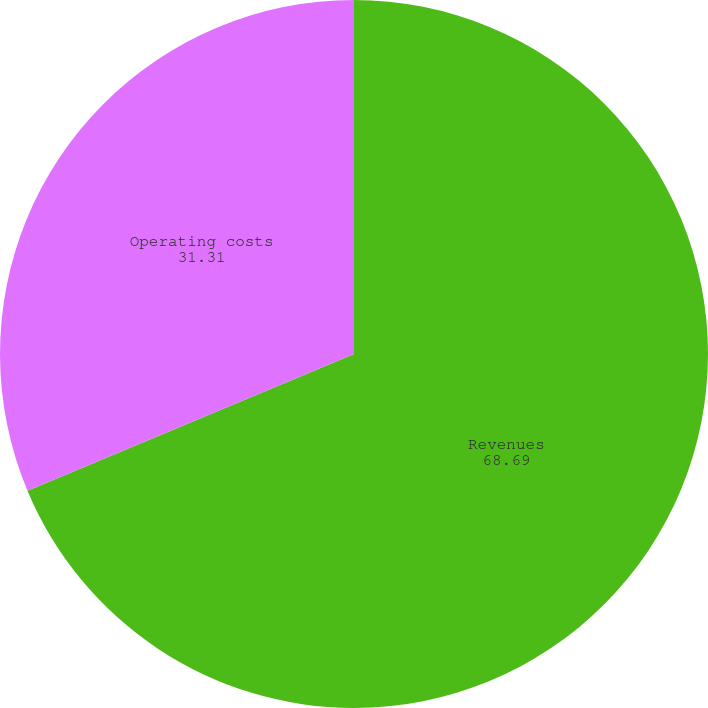Convert chart. <chart><loc_0><loc_0><loc_500><loc_500><pie_chart><fcel>Revenues<fcel>Operating costs<nl><fcel>68.69%<fcel>31.31%<nl></chart> 